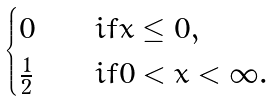Convert formula to latex. <formula><loc_0><loc_0><loc_500><loc_500>\begin{cases} 0 & \quad i f x \leq 0 , \\ \frac { 1 } { 2 } & \quad i f 0 < x < \infty . \end{cases}</formula> 